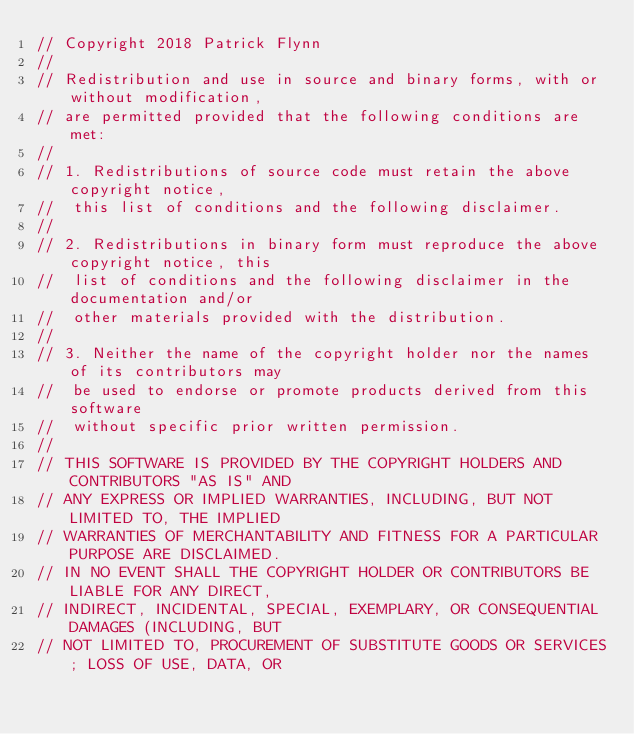<code> <loc_0><loc_0><loc_500><loc_500><_C++_>// Copyright 2018 Patrick Flynn
//
// Redistribution and use in source and binary forms, with or without modification,
// are permitted provided that the following conditions are met:
//
// 1. Redistributions of source code must retain the above copyright notice,
//	this list of conditions and the following disclaimer.
//
// 2. Redistributions in binary form must reproduce the above copyright notice, this
//	list of conditions and the following disclaimer in the documentation and/or
//	other materials provided with the distribution.
//
// 3. Neither the name of the copyright holder nor the names of its contributors may
//	be used to endorse or promote products derived from this software
//	without specific prior written permission.
//
// THIS SOFTWARE IS PROVIDED BY THE COPYRIGHT HOLDERS AND CONTRIBUTORS "AS IS" AND
// ANY EXPRESS OR IMPLIED WARRANTIES, INCLUDING, BUT NOT LIMITED TO, THE IMPLIED
// WARRANTIES OF MERCHANTABILITY AND FITNESS FOR A PARTICULAR PURPOSE ARE DISCLAIMED.
// IN NO EVENT SHALL THE COPYRIGHT HOLDER OR CONTRIBUTORS BE LIABLE FOR ANY DIRECT,
// INDIRECT, INCIDENTAL, SPECIAL, EXEMPLARY, OR CONSEQUENTIAL DAMAGES (INCLUDING, BUT
// NOT LIMITED TO, PROCUREMENT OF SUBSTITUTE GOODS OR SERVICES; LOSS OF USE, DATA, OR</code> 